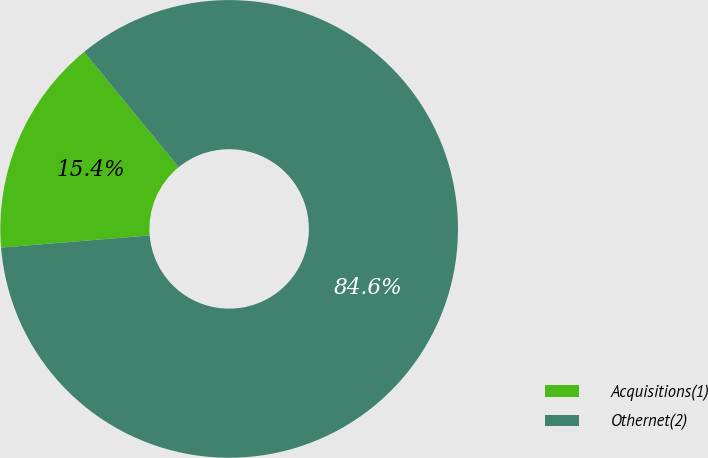<chart> <loc_0><loc_0><loc_500><loc_500><pie_chart><fcel>Acquisitions(1)<fcel>Othernet(2)<nl><fcel>15.38%<fcel>84.62%<nl></chart> 